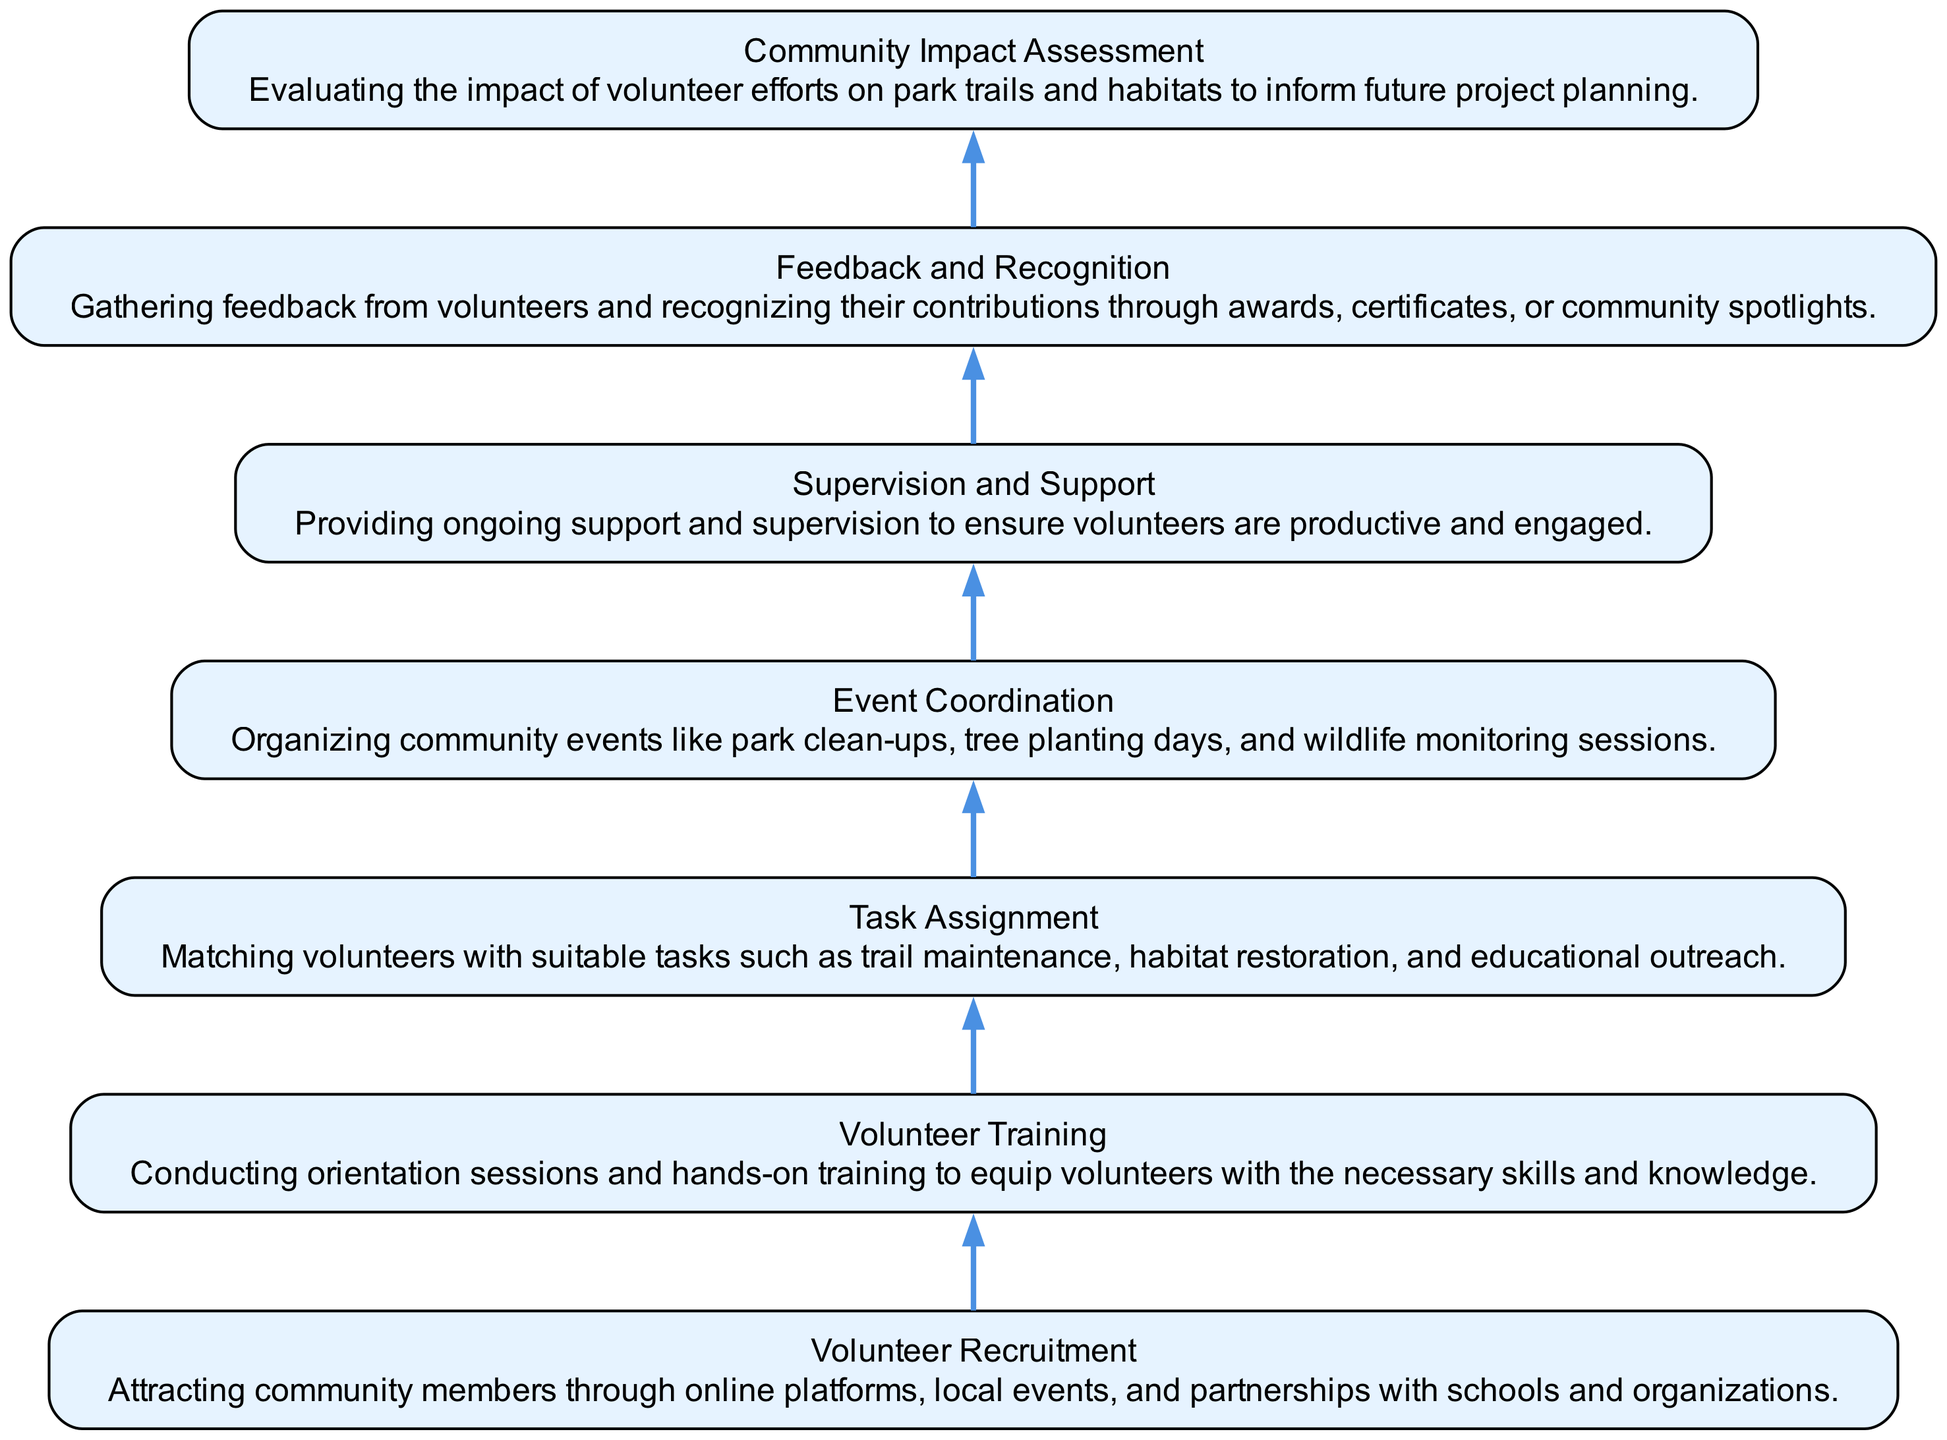What is the first step in the community engagement process? The first step in the diagram is "Volunteer Recruitment," which attracts community members before any further actions are taken.
Answer: Volunteer Recruitment How many main activities are outlined in the diagram? By counting the elements listed from the bottom to the top of the diagram, there are a total of 7 main activities included.
Answer: 7 What step provides ongoing support to volunteers? The step that provides ongoing support to volunteers is "Supervision and Support," ensuring they remain productive and engaged during their tasks.
Answer: Supervision and Support Which activity directly follows "Task Assignment" in the process? "Event Coordination" is the activity that comes immediately after "Task Assignment," meaning it is the next step once volunteers are assigned their tasks.
Answer: Event Coordination Which two steps focus on assessing and recognizing volunteer contributions? The two steps that focus on this are "Feedback and Recognition," which gathers insights from volunteers, and "Community Impact Assessment," which evaluates their contributions to planning future efforts.
Answer: Feedback and Recognition; Community Impact Assessment What does the "Volunteer Training" step involve? "Volunteer Training" involves conducting orientation sessions and hands-on training to prepare volunteers with the skills needed for their roles.
Answer: Conducting orientation sessions and hands-on training What is the primary purpose of the "Community Impact Assessment"? The primary purpose is to evaluate how volunteer efforts have affected park trails and habitats, which helps guide future project planning.
Answer: Evaluating the impact of volunteer efforts How many edges are present in the diagram? There are 6 edges present, as each activity is connected sequentially to the next, starting from "Volunteer Recruitment" down to "Community Impact Assessment."
Answer: 6 What happens after "Event Coordination"? After "Event Coordination," the next step in the flow is "Supervision and Support," signifying the ongoing assistance provided to the volunteers post-event.
Answer: Supervision and Support 